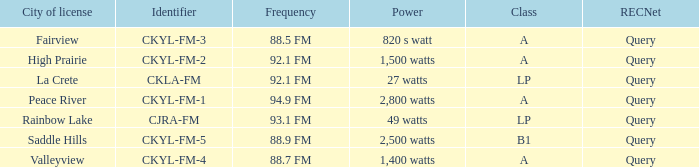5 fm frequency? 820 s watt. 